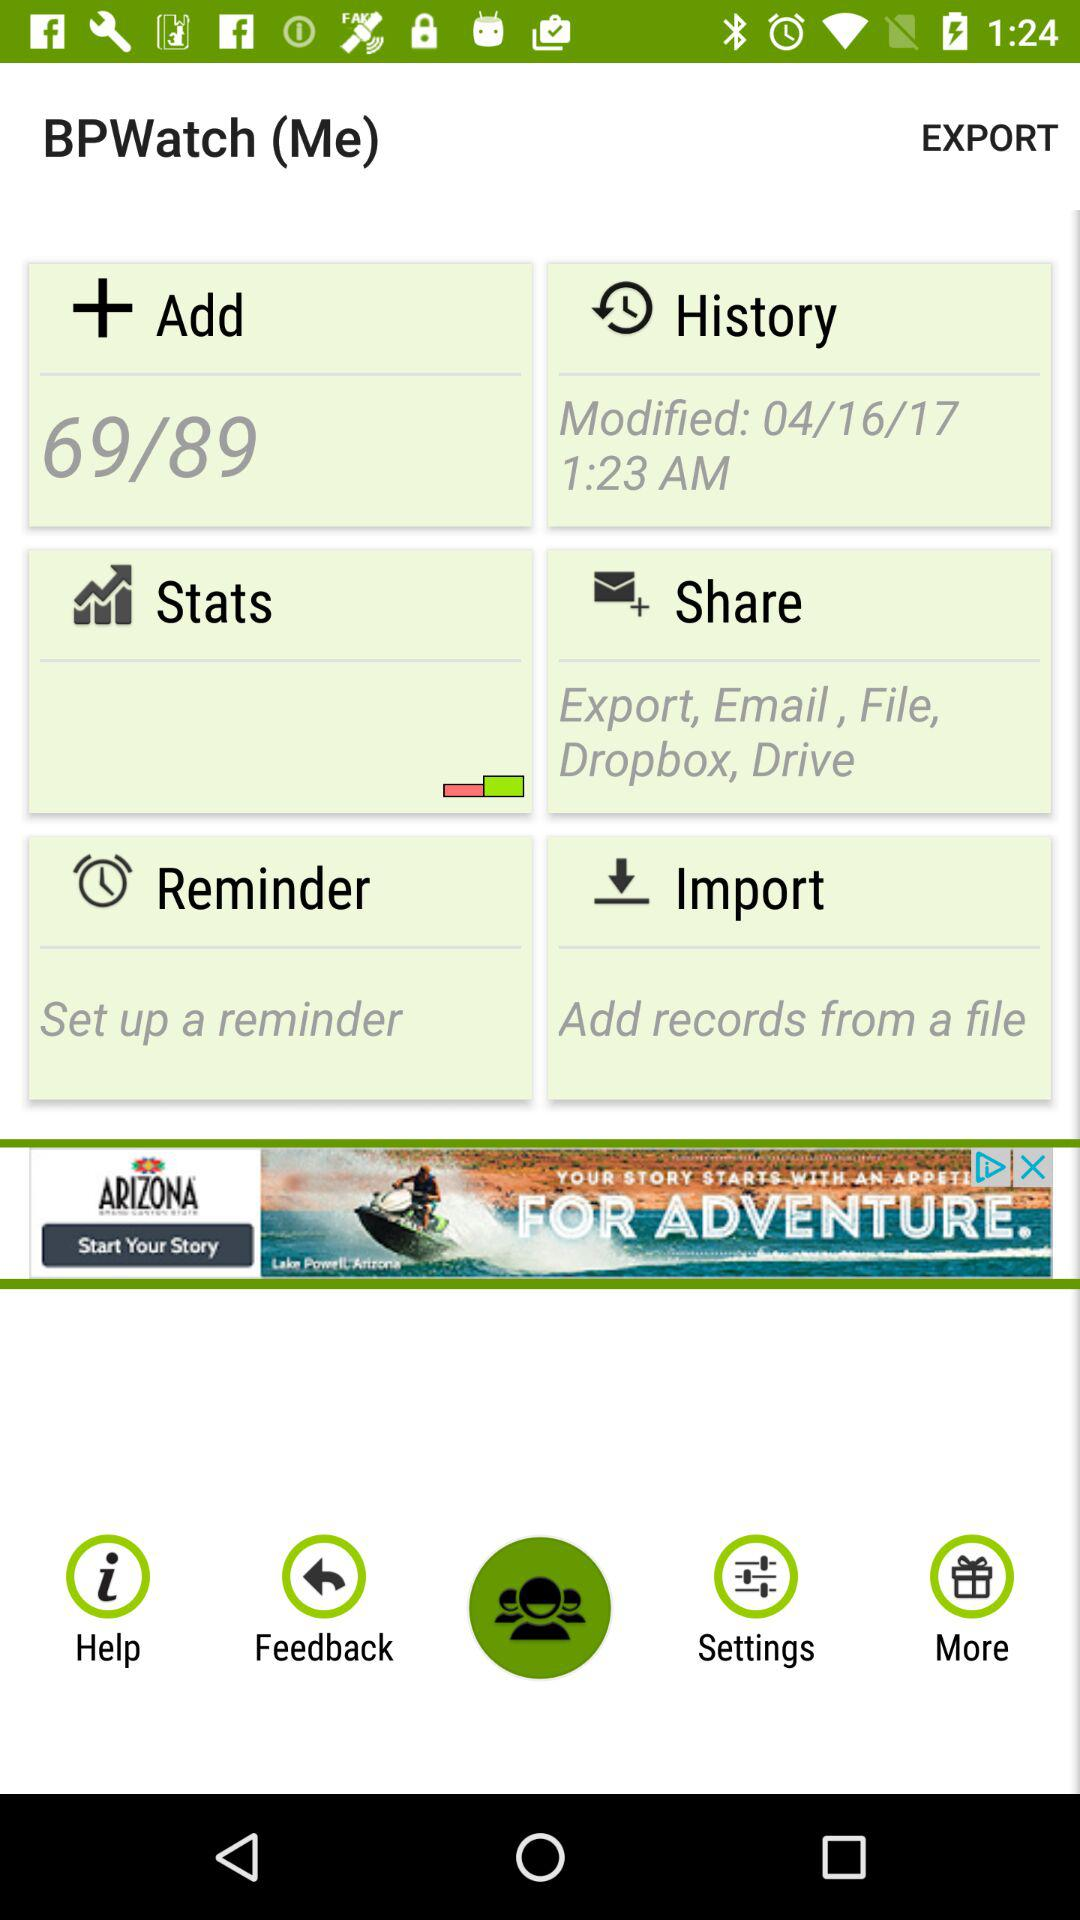What is the BP in the "Add" option? The BP is 69/89. 